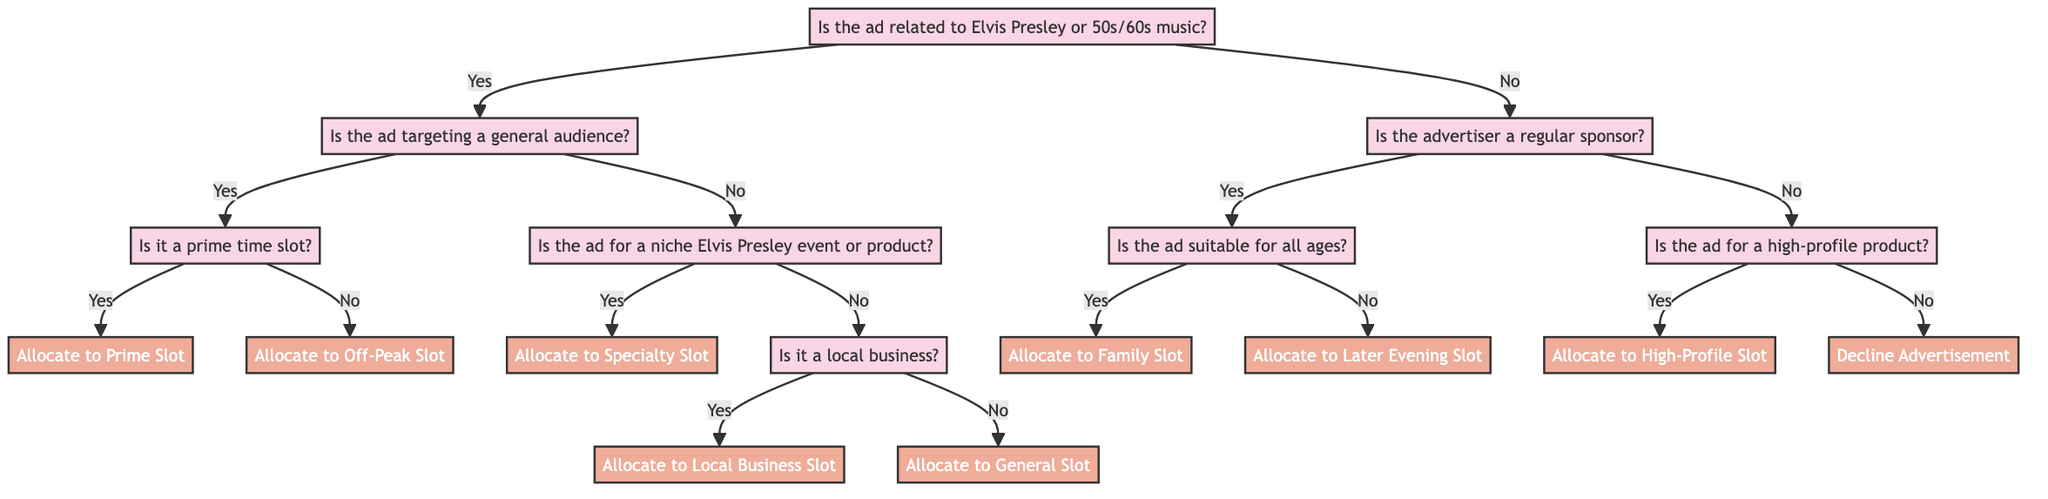What is the first question in the diagram? The first question in the diagram is about whether the advertisement is related to Elvis Presley or 50s/60s music. This question is positioned at the root of the decision tree.
Answer: Is the advertisement related to Elvis Presley or 50s/60s music? How many decision nodes are in the diagram? To find the number of decision nodes, we count the nodes that involve making a choice. The decision nodes are those where a "yes" or "no" answer leads to further questions or conclusions. There are five decision nodes in total.
Answer: 5 What happens if the advertisement is for a niche Elvis Presley event? If the advertisement is for a niche Elvis Presley event or product, the next question checks whether it is targeting a general audience. If the answer is "yes," it leads to the "Allocate to Specialty Slot" conclusion directly.
Answer: Allocate to Specialty Slot What is the outcome if the ad is not related to Elvis Presley? If the ad is not related to Elvis Presley or 50s/60s music, the flow moves to check if the advertiser is a regular sponsor. Depending on that evaluation, it could lead to two possible branches: one for regular sponsors and the other for those who are not.
Answer: Is the advertiser a regular sponsor? If an advertisement is suitable for all ages, where will it be allocated? If the advertisement is suitable for all ages, we follow the decision path to the question regarding the advertiser. If they are a regular sponsor, the next outcome is to allocate the ad to the "Family Slot."
Answer: Allocate to Family Slot What leads to the "Decline Advertisement" conclusion? The "Decline Advertisement" conclusion comes into play when the advertisement is not related to Elvis Presley, the advertiser isn't a regular sponsor, and the ad is not for a high-profile product. This represents the final decision in that pathway.
Answer: Decline Advertisement Which slot is allocated if the advertisement is a local business? If the advertisement is for a local business, the decision path diverges from the niche Elvis Presley question; it will lead directly to "Allocate to Local Business Slot" if the answer to the local business question is "yes."
Answer: Allocate to Local Business Slot What question follows if the advertisement targets a general audience? If the advertisement targets a general audience, the next question asks if it is a prime time slot, leading to a decision on whether to allocate it to a prime slot or an off-peak slot accordingly.
Answer: Is it a prime time slot? 